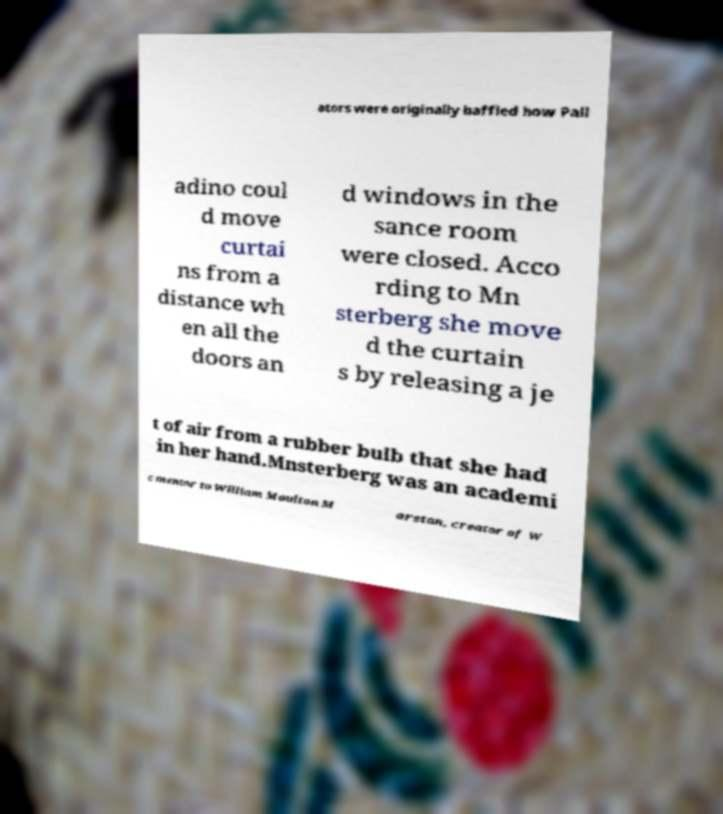What messages or text are displayed in this image? I need them in a readable, typed format. ators were originally baffled how Pall adino coul d move curtai ns from a distance wh en all the doors an d windows in the sance room were closed. Acco rding to Mn sterberg she move d the curtain s by releasing a je t of air from a rubber bulb that she had in her hand.Mnsterberg was an academi c mentor to William Moulton M arston, creator of W 